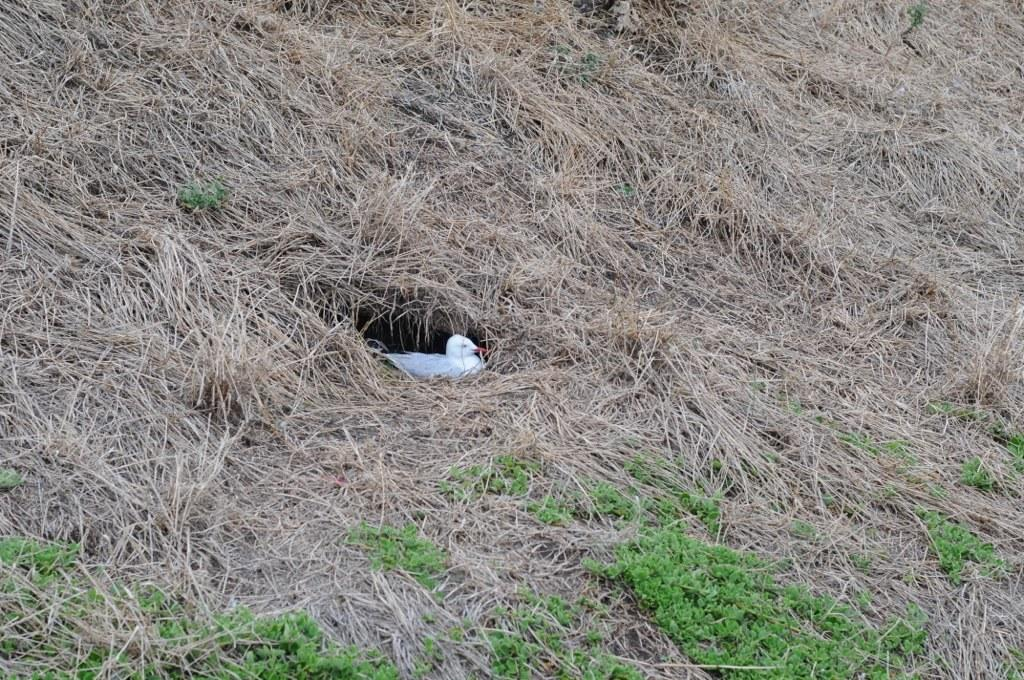What type of animal is in the image? There is a pigeon in the image. Where is the pigeon located? The pigeon is on the surface of the grass. What type of bread is the pigeon holding in its beak in the image? There is no bread present in the image; the pigeon is simply standing on the grass. 